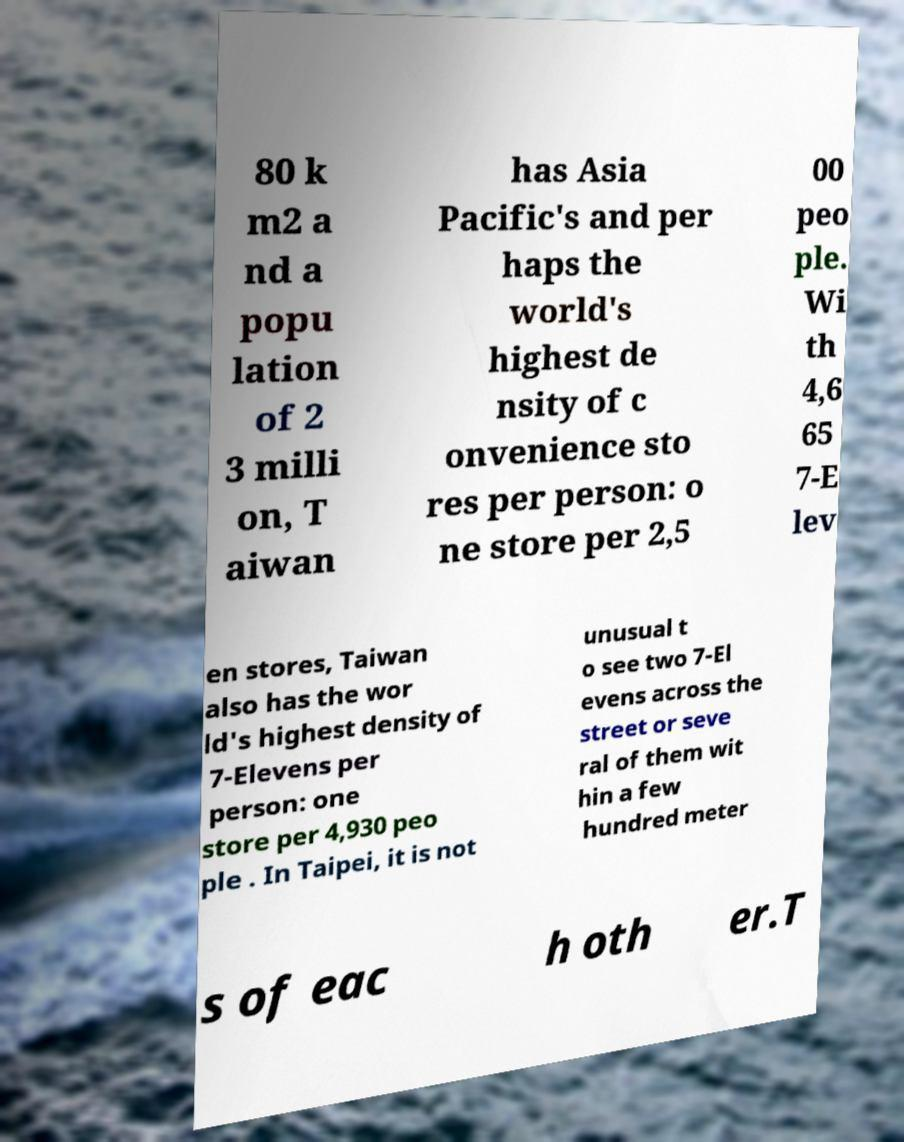I need the written content from this picture converted into text. Can you do that? 80 k m2 a nd a popu lation of 2 3 milli on, T aiwan has Asia Pacific's and per haps the world's highest de nsity of c onvenience sto res per person: o ne store per 2,5 00 peo ple. Wi th 4,6 65 7-E lev en stores, Taiwan also has the wor ld's highest density of 7-Elevens per person: one store per 4,930 peo ple . In Taipei, it is not unusual t o see two 7-El evens across the street or seve ral of them wit hin a few hundred meter s of eac h oth er.T 